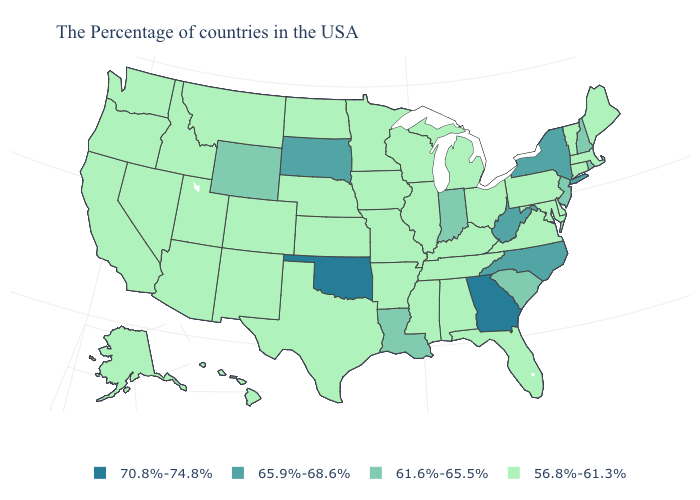Is the legend a continuous bar?
Concise answer only. No. What is the value of Massachusetts?
Concise answer only. 56.8%-61.3%. What is the lowest value in the South?
Quick response, please. 56.8%-61.3%. Name the states that have a value in the range 61.6%-65.5%?
Keep it brief. Rhode Island, New Hampshire, New Jersey, South Carolina, Indiana, Louisiana, Wyoming. Among the states that border New York , does New Jersey have the lowest value?
Write a very short answer. No. Name the states that have a value in the range 61.6%-65.5%?
Short answer required. Rhode Island, New Hampshire, New Jersey, South Carolina, Indiana, Louisiana, Wyoming. Name the states that have a value in the range 65.9%-68.6%?
Give a very brief answer. New York, North Carolina, West Virginia, South Dakota. What is the highest value in the West ?
Answer briefly. 61.6%-65.5%. What is the value of Arkansas?
Quick response, please. 56.8%-61.3%. Among the states that border North Carolina , does Tennessee have the lowest value?
Write a very short answer. Yes. What is the value of Wyoming?
Write a very short answer. 61.6%-65.5%. What is the value of Oregon?
Concise answer only. 56.8%-61.3%. Does North Dakota have the lowest value in the MidWest?
Quick response, please. Yes. Is the legend a continuous bar?
Answer briefly. No. Which states have the lowest value in the USA?
Be succinct. Maine, Massachusetts, Vermont, Connecticut, Delaware, Maryland, Pennsylvania, Virginia, Ohio, Florida, Michigan, Kentucky, Alabama, Tennessee, Wisconsin, Illinois, Mississippi, Missouri, Arkansas, Minnesota, Iowa, Kansas, Nebraska, Texas, North Dakota, Colorado, New Mexico, Utah, Montana, Arizona, Idaho, Nevada, California, Washington, Oregon, Alaska, Hawaii. 